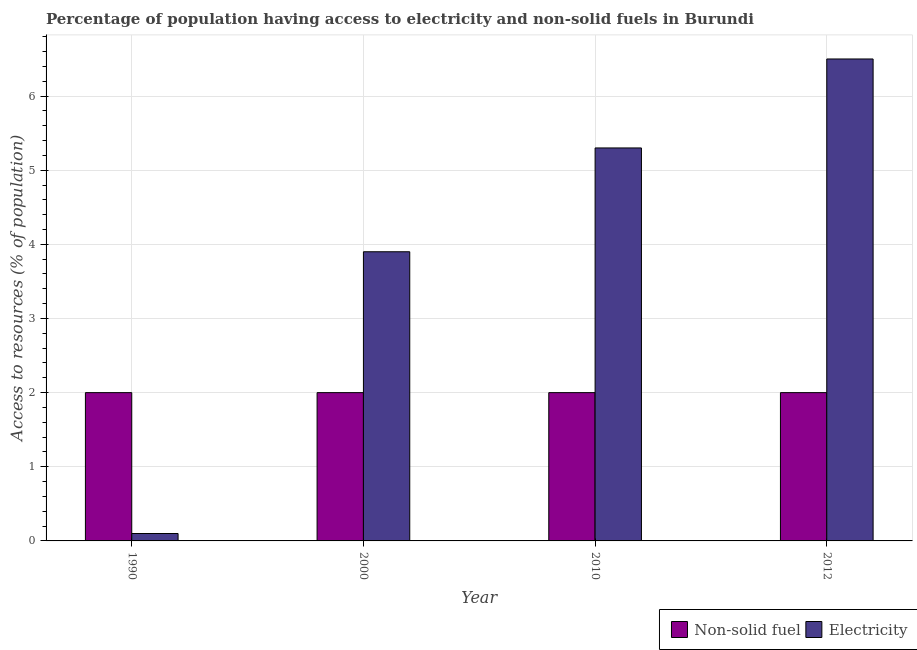How many groups of bars are there?
Provide a short and direct response. 4. What is the label of the 1st group of bars from the left?
Keep it short and to the point. 1990. Across all years, what is the maximum percentage of population having access to non-solid fuel?
Provide a succinct answer. 2. In which year was the percentage of population having access to electricity maximum?
Your answer should be very brief. 2012. What is the difference between the percentage of population having access to electricity in 2010 and that in 2012?
Make the answer very short. -1.2. What is the average percentage of population having access to electricity per year?
Ensure brevity in your answer.  3.95. In the year 2000, what is the difference between the percentage of population having access to electricity and percentage of population having access to non-solid fuel?
Your answer should be very brief. 0. In how many years, is the percentage of population having access to non-solid fuel greater than 4.4 %?
Make the answer very short. 0. What is the ratio of the percentage of population having access to electricity in 2010 to that in 2012?
Keep it short and to the point. 0.82. Is the percentage of population having access to non-solid fuel in 2000 less than that in 2012?
Offer a terse response. No. Is the difference between the percentage of population having access to non-solid fuel in 2010 and 2012 greater than the difference between the percentage of population having access to electricity in 2010 and 2012?
Provide a short and direct response. No. What is the difference between the highest and the second highest percentage of population having access to electricity?
Your response must be concise. 1.2. In how many years, is the percentage of population having access to non-solid fuel greater than the average percentage of population having access to non-solid fuel taken over all years?
Give a very brief answer. 0. Is the sum of the percentage of population having access to non-solid fuel in 2010 and 2012 greater than the maximum percentage of population having access to electricity across all years?
Offer a very short reply. Yes. What does the 2nd bar from the left in 2000 represents?
Your answer should be very brief. Electricity. What does the 1st bar from the right in 2012 represents?
Ensure brevity in your answer.  Electricity. How many bars are there?
Make the answer very short. 8. Are all the bars in the graph horizontal?
Your response must be concise. No. How many years are there in the graph?
Your response must be concise. 4. Are the values on the major ticks of Y-axis written in scientific E-notation?
Offer a very short reply. No. Does the graph contain any zero values?
Offer a very short reply. No. Where does the legend appear in the graph?
Your answer should be compact. Bottom right. How many legend labels are there?
Your answer should be very brief. 2. How are the legend labels stacked?
Your answer should be compact. Horizontal. What is the title of the graph?
Keep it short and to the point. Percentage of population having access to electricity and non-solid fuels in Burundi. What is the label or title of the X-axis?
Provide a short and direct response. Year. What is the label or title of the Y-axis?
Provide a succinct answer. Access to resources (% of population). What is the Access to resources (% of population) in Non-solid fuel in 1990?
Your answer should be compact. 2. What is the Access to resources (% of population) in Non-solid fuel in 2000?
Provide a succinct answer. 2. What is the Access to resources (% of population) in Non-solid fuel in 2010?
Your answer should be very brief. 2. What is the Access to resources (% of population) in Electricity in 2010?
Ensure brevity in your answer.  5.3. What is the Access to resources (% of population) in Non-solid fuel in 2012?
Give a very brief answer. 2. What is the Access to resources (% of population) in Electricity in 2012?
Provide a short and direct response. 6.5. Across all years, what is the maximum Access to resources (% of population) in Non-solid fuel?
Ensure brevity in your answer.  2. Across all years, what is the minimum Access to resources (% of population) of Non-solid fuel?
Your response must be concise. 2. What is the difference between the Access to resources (% of population) of Non-solid fuel in 1990 and that in 2010?
Give a very brief answer. 0. What is the difference between the Access to resources (% of population) of Non-solid fuel in 1990 and that in 2012?
Offer a terse response. 0. What is the difference between the Access to resources (% of population) of Electricity in 1990 and that in 2012?
Your response must be concise. -6.4. What is the difference between the Access to resources (% of population) of Electricity in 2000 and that in 2012?
Provide a succinct answer. -2.6. What is the difference between the Access to resources (% of population) of Non-solid fuel in 2010 and that in 2012?
Offer a very short reply. 0. What is the difference between the Access to resources (% of population) of Electricity in 2010 and that in 2012?
Make the answer very short. -1.2. What is the difference between the Access to resources (% of population) of Non-solid fuel in 1990 and the Access to resources (% of population) of Electricity in 2012?
Your answer should be very brief. -4.5. What is the difference between the Access to resources (% of population) of Non-solid fuel in 2000 and the Access to resources (% of population) of Electricity in 2010?
Provide a succinct answer. -3.3. What is the difference between the Access to resources (% of population) in Non-solid fuel in 2010 and the Access to resources (% of population) in Electricity in 2012?
Ensure brevity in your answer.  -4.5. What is the average Access to resources (% of population) of Electricity per year?
Offer a very short reply. 3.95. In the year 1990, what is the difference between the Access to resources (% of population) in Non-solid fuel and Access to resources (% of population) in Electricity?
Offer a very short reply. 1.9. In the year 2010, what is the difference between the Access to resources (% of population) in Non-solid fuel and Access to resources (% of population) in Electricity?
Your response must be concise. -3.3. What is the ratio of the Access to resources (% of population) of Electricity in 1990 to that in 2000?
Keep it short and to the point. 0.03. What is the ratio of the Access to resources (% of population) of Non-solid fuel in 1990 to that in 2010?
Keep it short and to the point. 1. What is the ratio of the Access to resources (% of population) in Electricity in 1990 to that in 2010?
Keep it short and to the point. 0.02. What is the ratio of the Access to resources (% of population) of Electricity in 1990 to that in 2012?
Your answer should be very brief. 0.02. What is the ratio of the Access to resources (% of population) of Electricity in 2000 to that in 2010?
Make the answer very short. 0.74. What is the ratio of the Access to resources (% of population) in Non-solid fuel in 2000 to that in 2012?
Ensure brevity in your answer.  1. What is the ratio of the Access to resources (% of population) in Electricity in 2000 to that in 2012?
Your response must be concise. 0.6. What is the ratio of the Access to resources (% of population) of Non-solid fuel in 2010 to that in 2012?
Offer a terse response. 1. What is the ratio of the Access to resources (% of population) of Electricity in 2010 to that in 2012?
Give a very brief answer. 0.82. What is the difference between the highest and the second highest Access to resources (% of population) in Non-solid fuel?
Your answer should be compact. 0. 